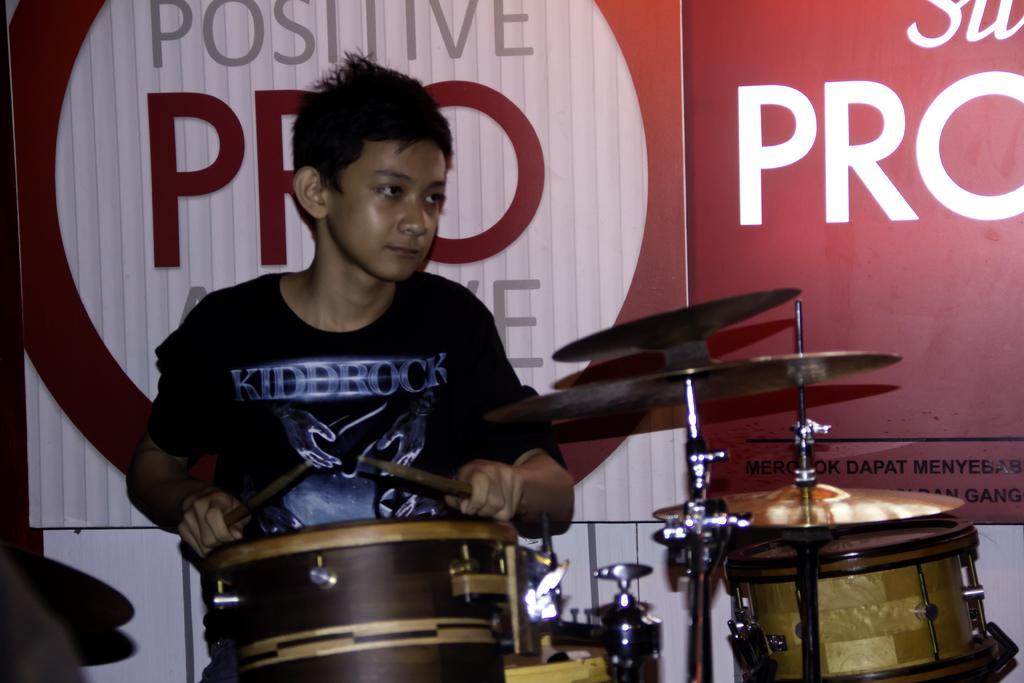Could you give a brief overview of what you see in this image? In this image I can see a boy next to a drum set. 